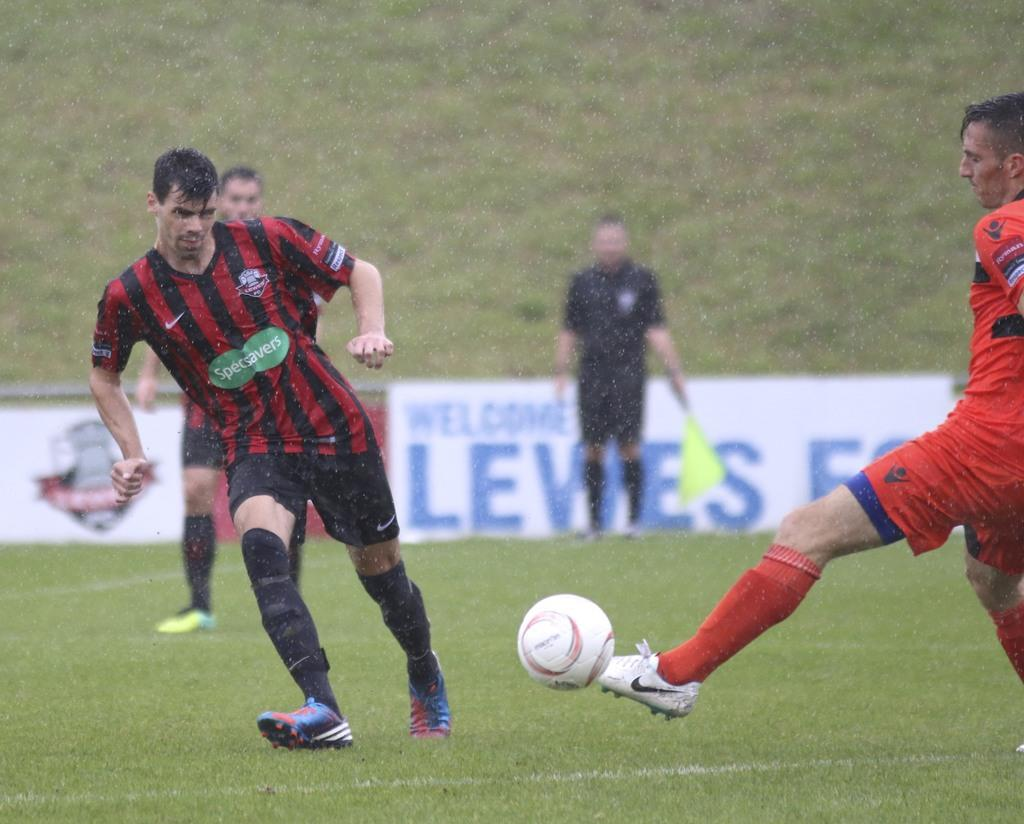What are the two men in the image doing? The two men in the image are playing football. What is the person with the flag doing? The person with the flag is standing in the image. How many men are standing in the image? There is one man standing in the image. What is the ground surface like in the image? There is grass on the ground in the image. What type of dress is the street wearing in the image? There is no street present in the image, and therefore no dress can be associated with it. 